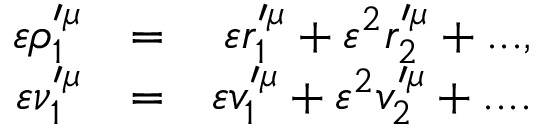<formula> <loc_0><loc_0><loc_500><loc_500>\begin{array} { r l r } { \varepsilon \rho _ { 1 } ^ { \prime \mu } } & { = } & { \varepsilon r _ { 1 } ^ { \prime \mu } + \varepsilon ^ { 2 } r _ { 2 } ^ { \prime \mu } + \dots , } \\ { \varepsilon \nu _ { 1 } ^ { \prime \mu } } & { = } & { \varepsilon v _ { 1 } ^ { \prime \mu } + \varepsilon ^ { 2 } v _ { 2 } ^ { \prime \mu } + \cdots } \end{array}</formula> 